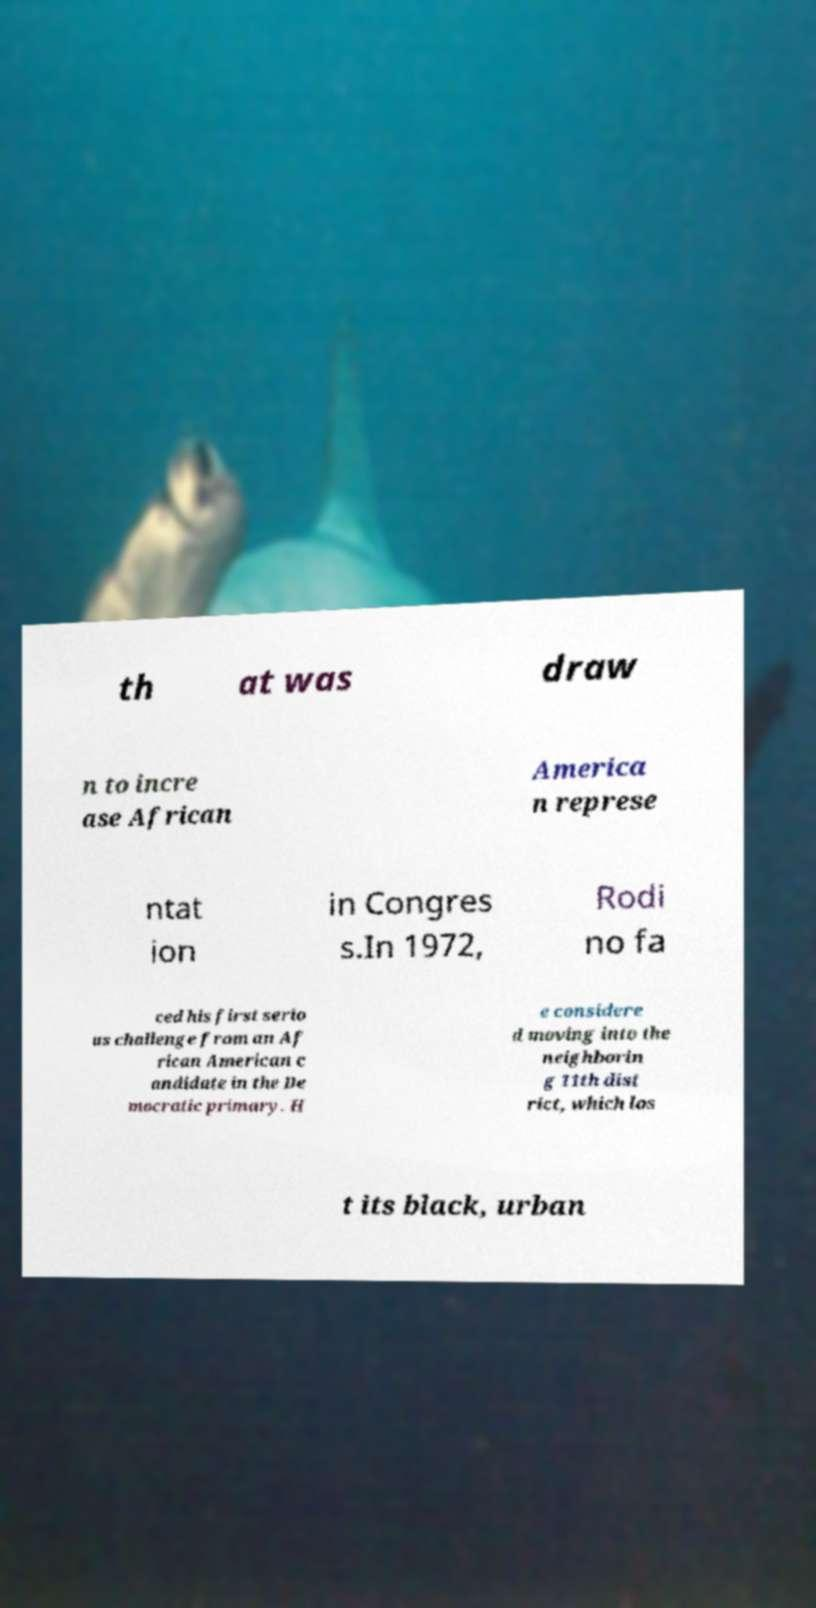I need the written content from this picture converted into text. Can you do that? th at was draw n to incre ase African America n represe ntat ion in Congres s.In 1972, Rodi no fa ced his first serio us challenge from an Af rican American c andidate in the De mocratic primary. H e considere d moving into the neighborin g 11th dist rict, which los t its black, urban 